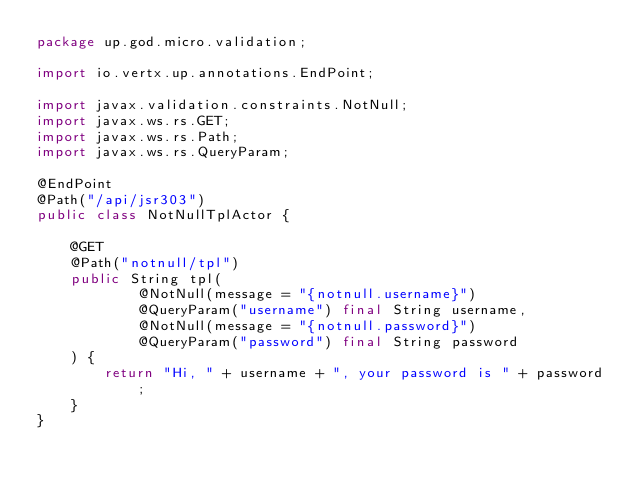<code> <loc_0><loc_0><loc_500><loc_500><_Java_>package up.god.micro.validation;

import io.vertx.up.annotations.EndPoint;

import javax.validation.constraints.NotNull;
import javax.ws.rs.GET;
import javax.ws.rs.Path;
import javax.ws.rs.QueryParam;

@EndPoint
@Path("/api/jsr303")
public class NotNullTplActor {

    @GET
    @Path("notnull/tpl")
    public String tpl(
            @NotNull(message = "{notnull.username}")
            @QueryParam("username") final String username,
            @NotNull(message = "{notnull.password}")
            @QueryParam("password") final String password
    ) {
        return "Hi, " + username + ", your password is " + password;
    }
}
</code> 